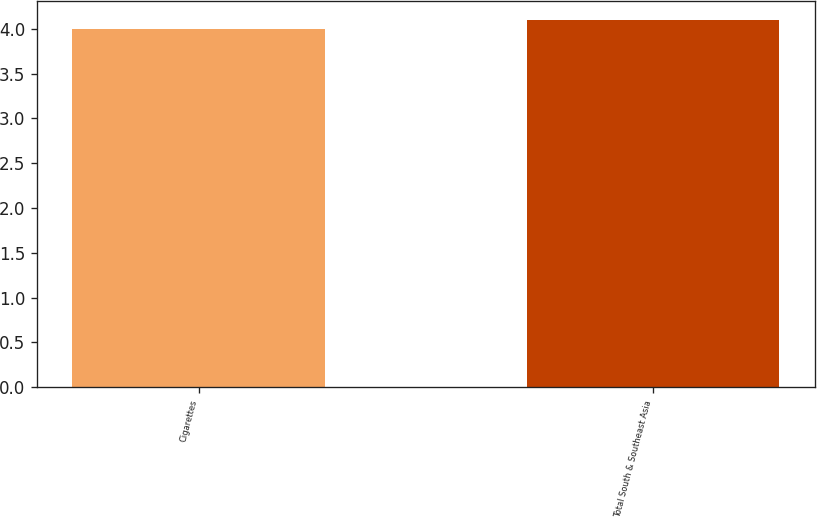Convert chart to OTSL. <chart><loc_0><loc_0><loc_500><loc_500><bar_chart><fcel>Cigarettes<fcel>Total South & Southeast Asia<nl><fcel>4<fcel>4.1<nl></chart> 